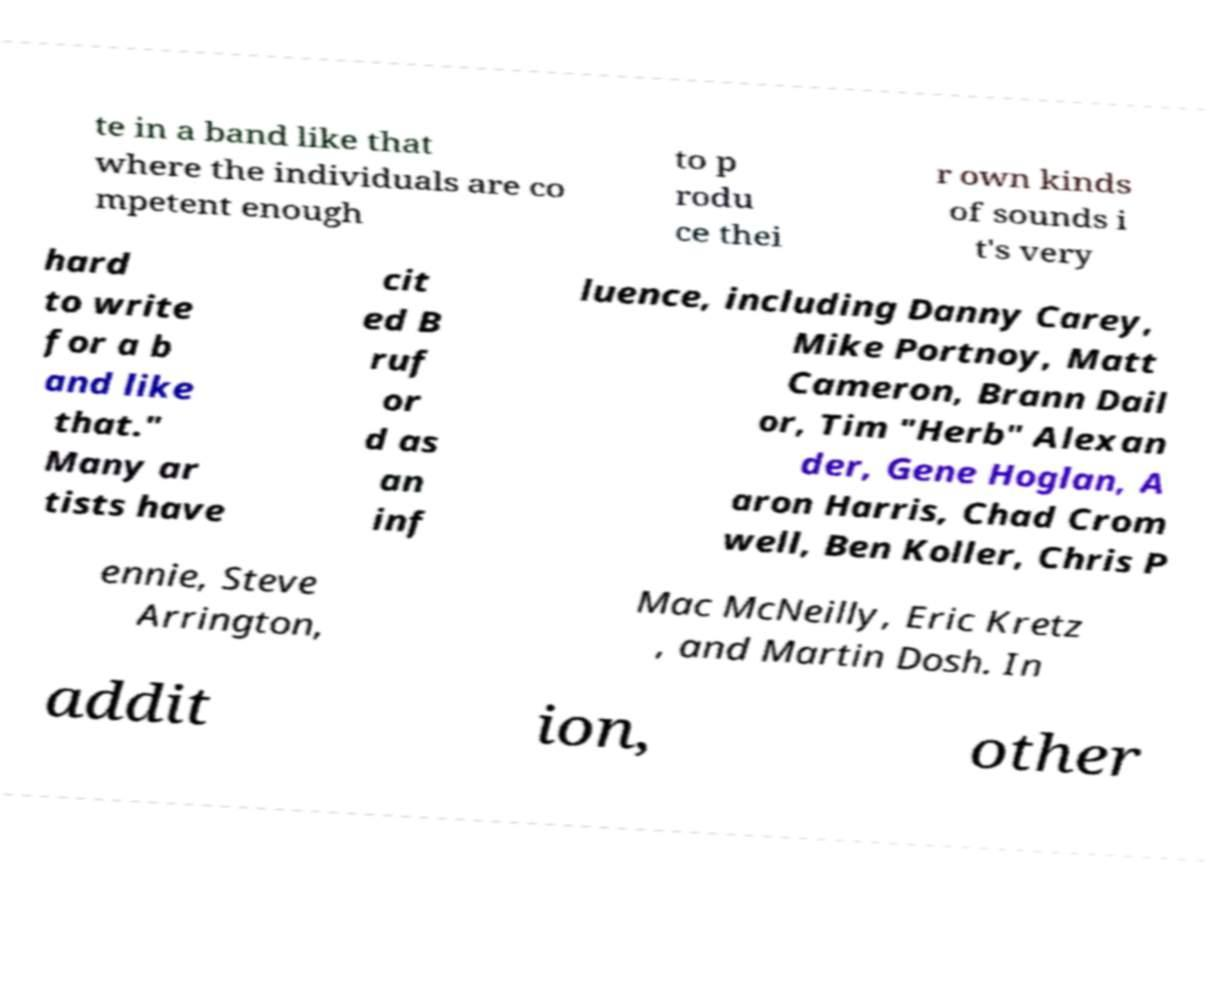There's text embedded in this image that I need extracted. Can you transcribe it verbatim? te in a band like that where the individuals are co mpetent enough to p rodu ce thei r own kinds of sounds i t's very hard to write for a b and like that." Many ar tists have cit ed B ruf or d as an inf luence, including Danny Carey, Mike Portnoy, Matt Cameron, Brann Dail or, Tim "Herb" Alexan der, Gene Hoglan, A aron Harris, Chad Crom well, Ben Koller, Chris P ennie, Steve Arrington, Mac McNeilly, Eric Kretz , and Martin Dosh. In addit ion, other 